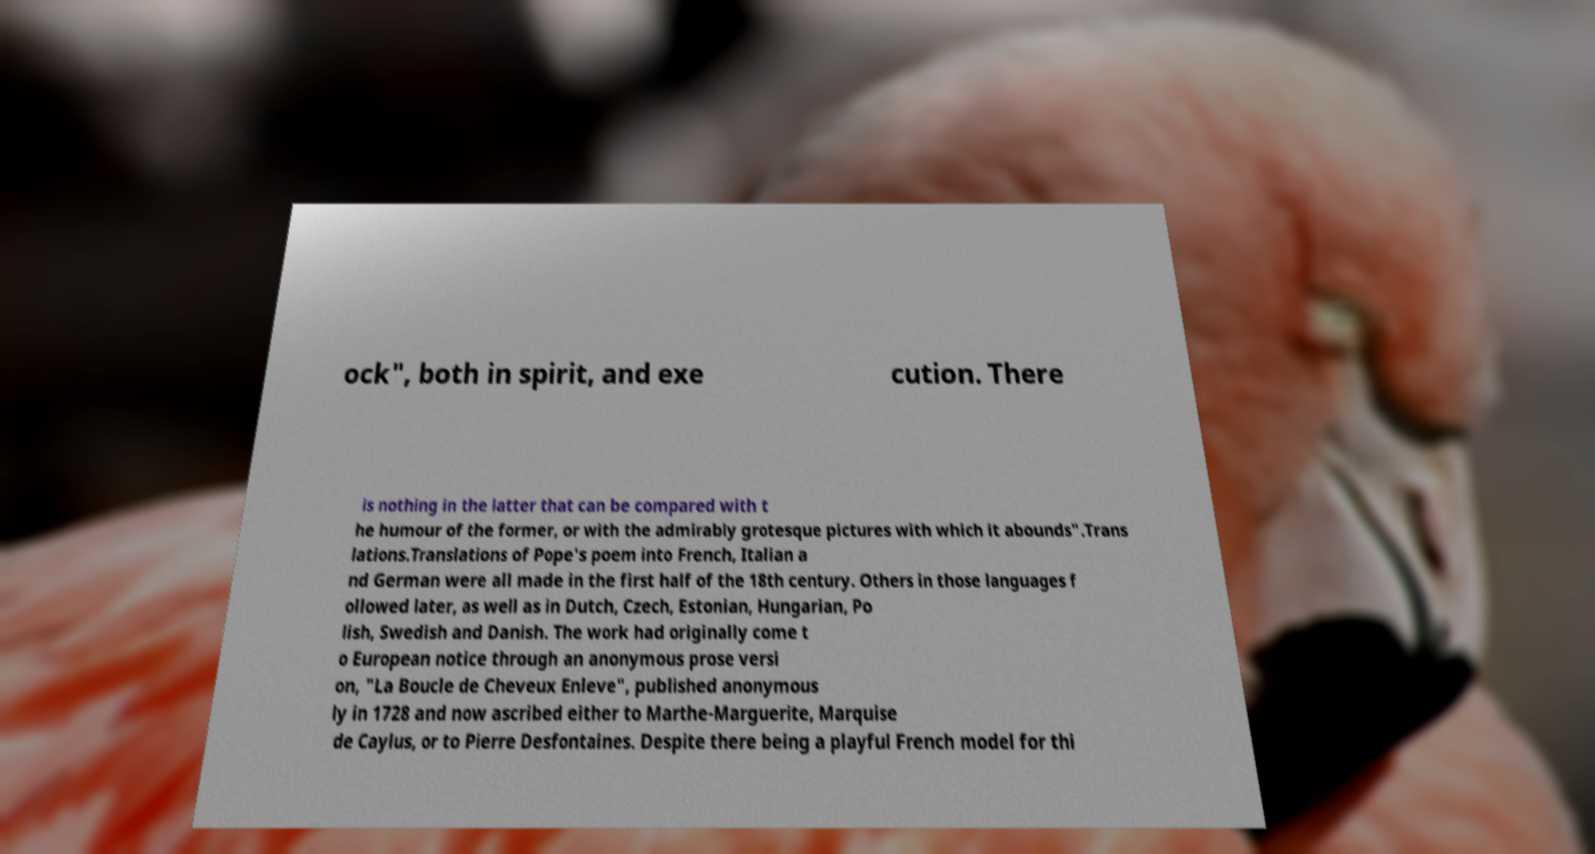Could you extract and type out the text from this image? ock", both in spirit, and exe cution. There is nothing in the latter that can be compared with t he humour of the former, or with the admirably grotesque pictures with which it abounds".Trans lations.Translations of Pope's poem into French, Italian a nd German were all made in the first half of the 18th century. Others in those languages f ollowed later, as well as in Dutch, Czech, Estonian, Hungarian, Po lish, Swedish and Danish. The work had originally come t o European notice through an anonymous prose versi on, "La Boucle de Cheveux Enleve", published anonymous ly in 1728 and now ascribed either to Marthe-Marguerite, Marquise de Caylus, or to Pierre Desfontaines. Despite there being a playful French model for thi 